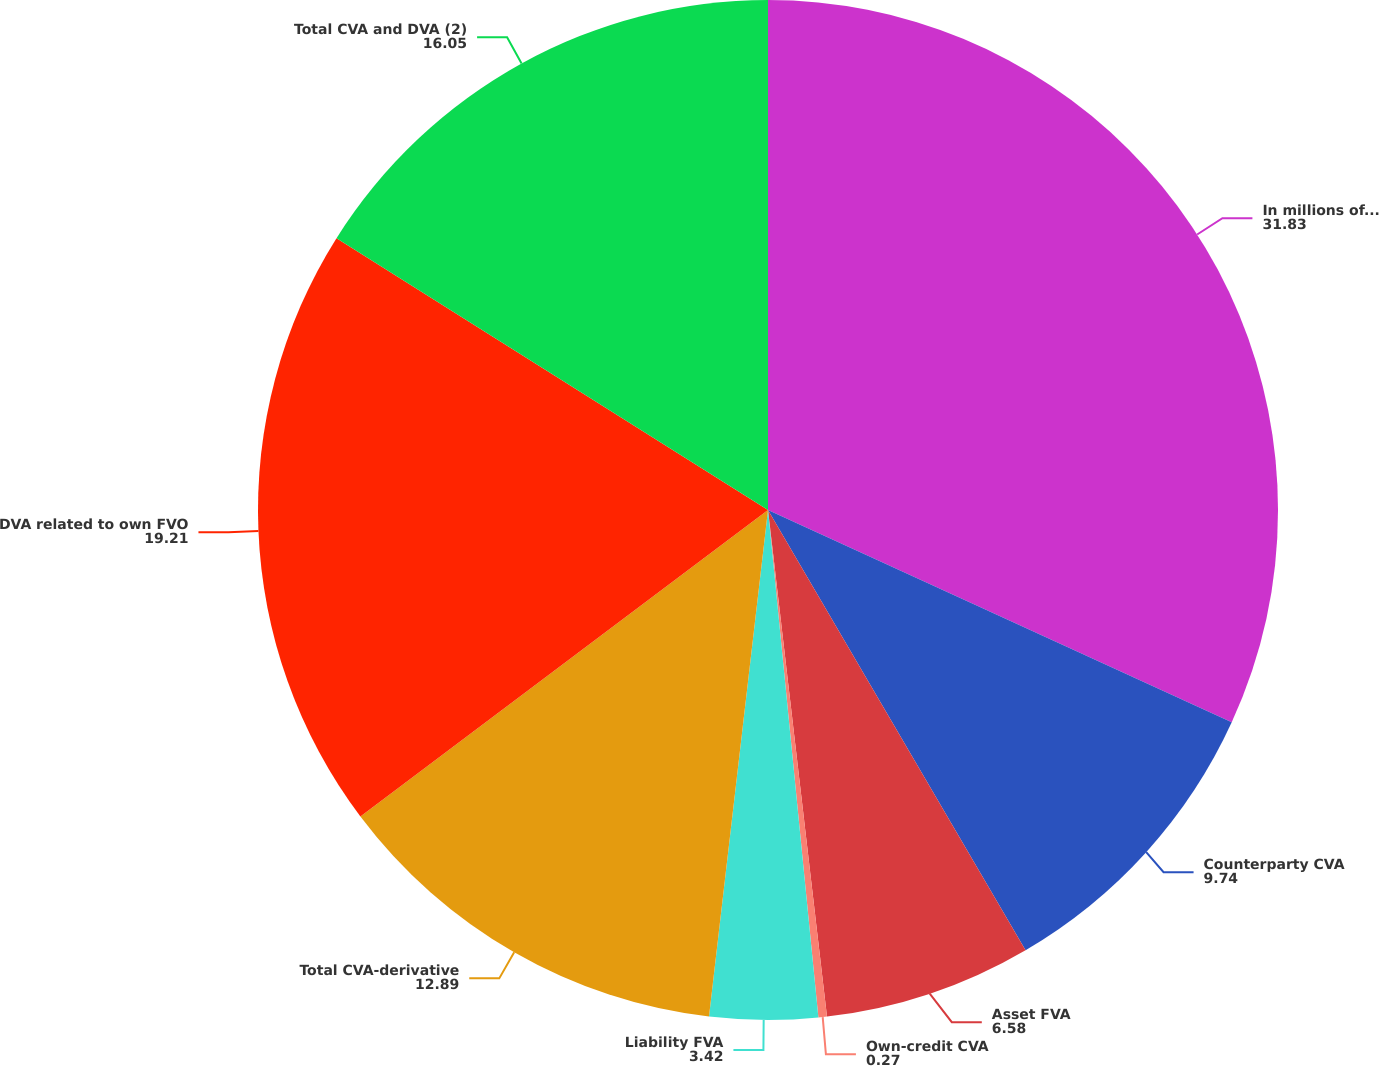<chart> <loc_0><loc_0><loc_500><loc_500><pie_chart><fcel>In millions of dollars<fcel>Counterparty CVA<fcel>Asset FVA<fcel>Own-credit CVA<fcel>Liability FVA<fcel>Total CVA-derivative<fcel>DVA related to own FVO<fcel>Total CVA and DVA (2)<nl><fcel>31.83%<fcel>9.74%<fcel>6.58%<fcel>0.27%<fcel>3.42%<fcel>12.89%<fcel>19.21%<fcel>16.05%<nl></chart> 